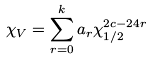Convert formula to latex. <formula><loc_0><loc_0><loc_500><loc_500>\chi _ { V } = \sum _ { r = 0 } ^ { k } a _ { r } \chi _ { 1 / 2 } ^ { 2 c - 2 4 r }</formula> 